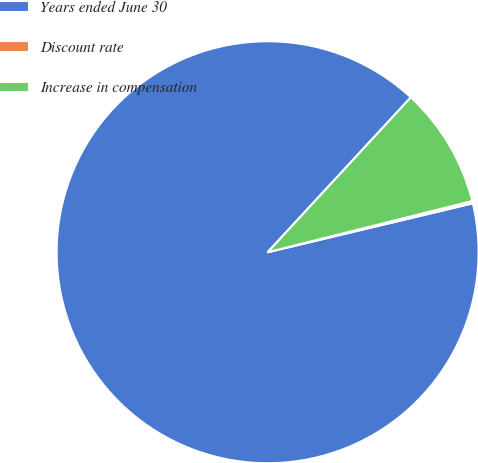Convert chart. <chart><loc_0><loc_0><loc_500><loc_500><pie_chart><fcel>Years ended June 30<fcel>Discount rate<fcel>Increase in compensation<nl><fcel>90.61%<fcel>0.18%<fcel>9.22%<nl></chart> 